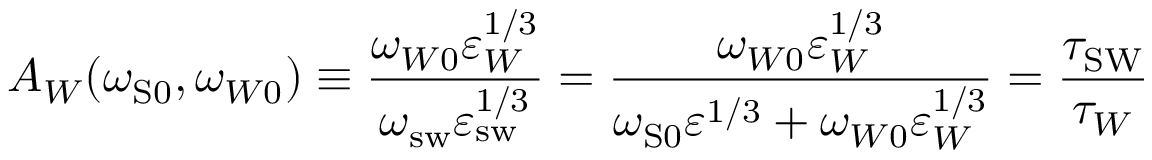Convert formula to latex. <formula><loc_0><loc_0><loc_500><loc_500>A _ { W } ( \omega _ { { S } 0 } , \omega _ { W 0 } ) \equiv \frac { \omega _ { W 0 } \varepsilon _ { W } ^ { 1 / 3 } } { \omega _ { s w } \varepsilon _ { s w } ^ { 1 / 3 } } = \frac { \omega _ { W 0 } \varepsilon _ { W } ^ { 1 / 3 } } { \omega _ { S 0 } \varepsilon ^ { 1 / 3 } + \omega _ { W 0 } \varepsilon _ { W } ^ { 1 / 3 } } = \frac { \tau _ { S W } } { \tau _ { W } }</formula> 